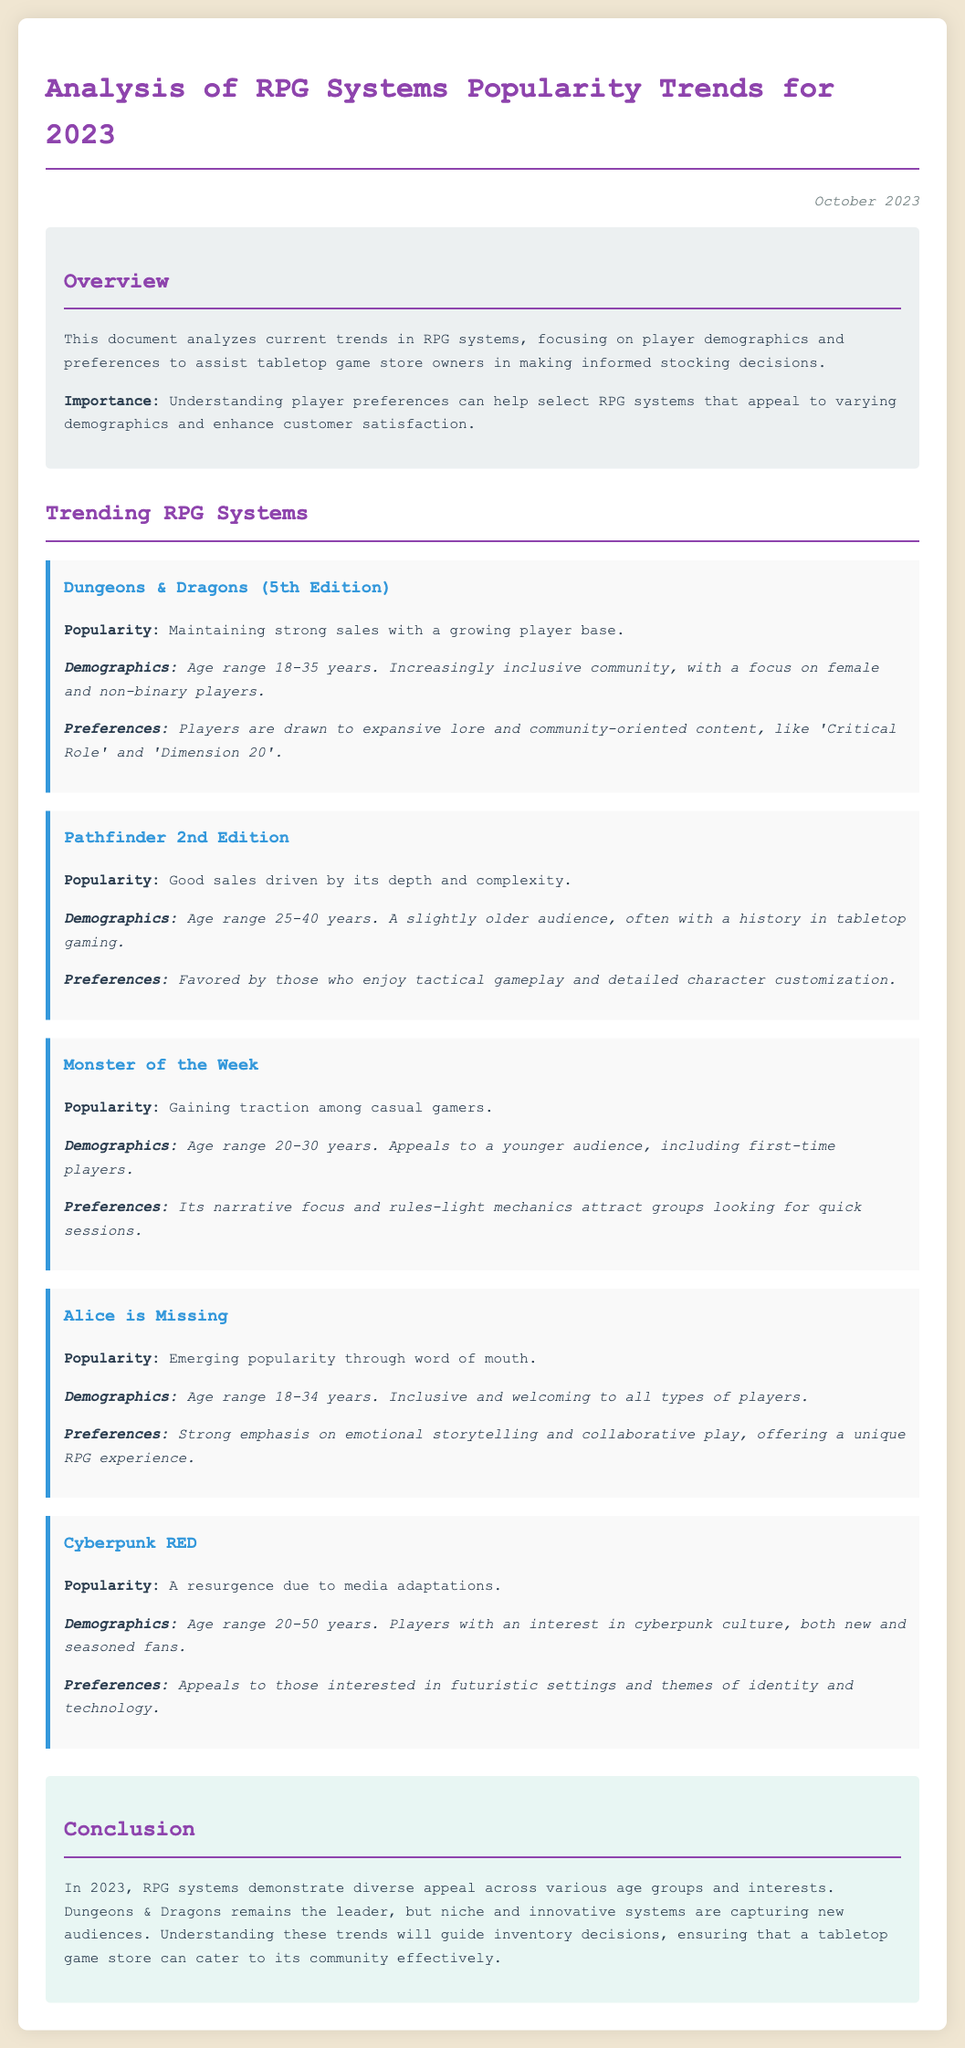What is the primary purpose of this document? The document aims to assist tabletop game store owners in making informed stocking decisions by analyzing player demographics and preferences related to RPG systems.
Answer: To assist tabletop game store owners Which RPG system is maintaining strong sales? Dungeons & Dragons (5th Edition) is noted for maintaining strong sales with a growing player base.
Answer: Dungeons & Dragons (5th Edition) What age range does the majority of Pathfinder 2nd Edition players fall into? The document states that Pathfinder 2nd Edition appeals to players aged 25-40 years.
Answer: 25-40 years Which RPG system emphasizes emotional storytelling? Alice is Missing is highlighted for its strong emphasis on emotional storytelling and collaborative play.
Answer: Alice is Missing What trend is associated with Cyberpunk RED? Cyberpunk RED is experiencing a resurgence due to media adaptations.
Answer: A resurgence due to media adaptations What demographic is increasingly represented in Dungeons & Dragons? The document mentions that Dungeons & Dragons is increasingly inclusive with a focus on female and non-binary players.
Answer: Female and non-binary players What is the target age range of Monster of the Week players? The age range for players of Monster of the Week is cited as 20-30 years.
Answer: 20-30 years Which RPG system is appealing to casual gamers? Monster of the Week is gaining traction among casual gamers.
Answer: Monster of the Week What theme do players of Cyberpunk RED show interest in? Players of Cyberpunk RED are described as having an interest in futuristic settings and themes of identity and technology.
Answer: Futuristic settings and themes of identity and technology 